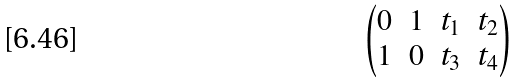Convert formula to latex. <formula><loc_0><loc_0><loc_500><loc_500>\begin{pmatrix} 0 & 1 & t _ { 1 } & t _ { 2 } \\ 1 & 0 & t _ { 3 } & t _ { 4 } \end{pmatrix}</formula> 